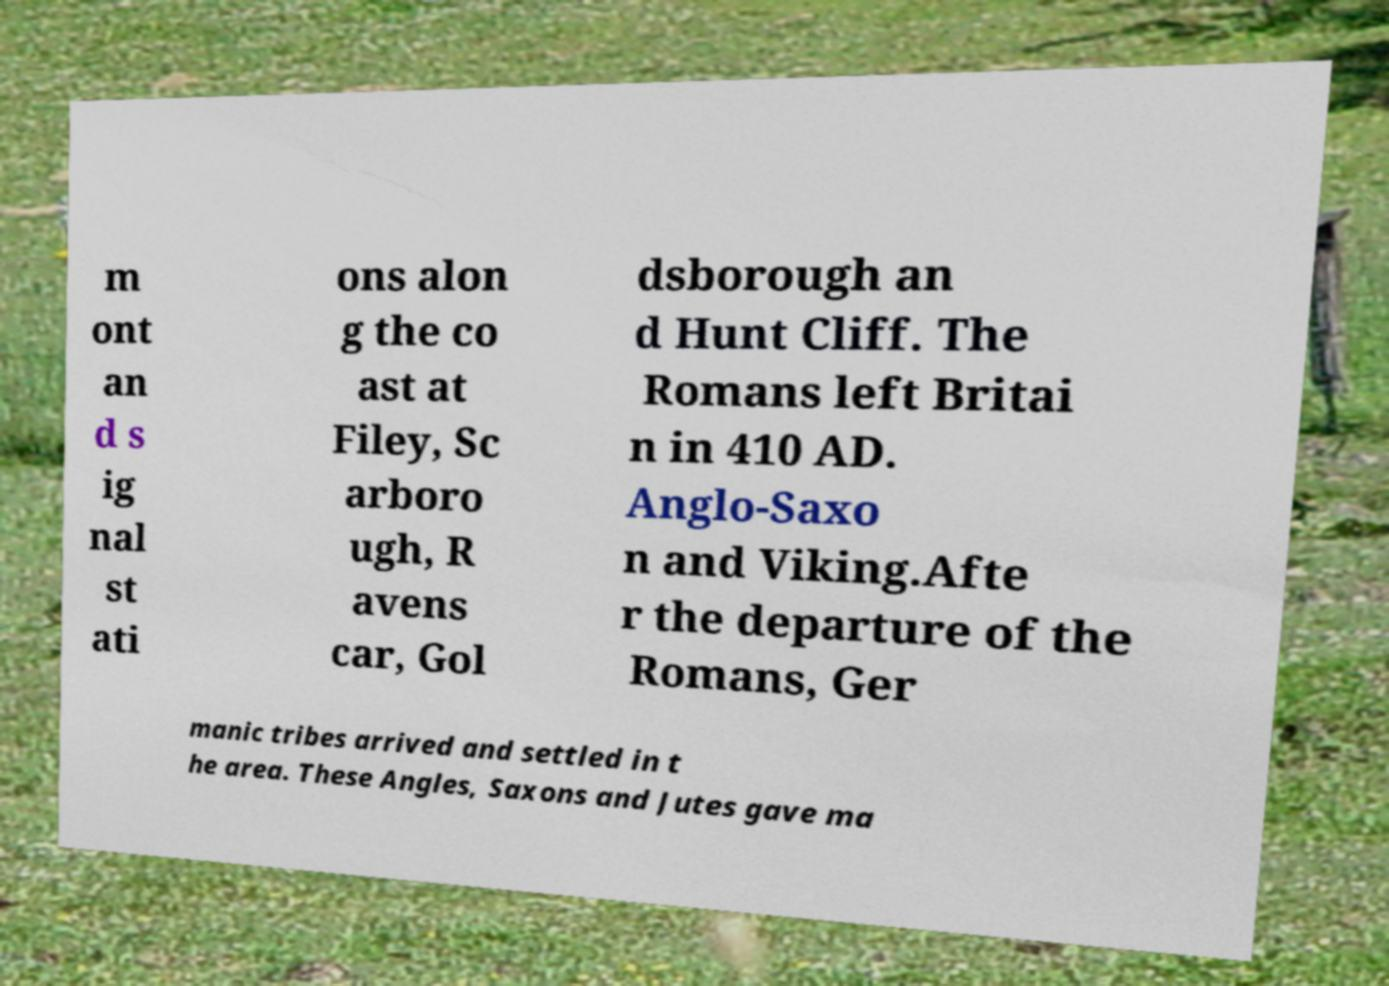Please read and relay the text visible in this image. What does it say? m ont an d s ig nal st ati ons alon g the co ast at Filey, Sc arboro ugh, R avens car, Gol dsborough an d Hunt Cliff. The Romans left Britai n in 410 AD. Anglo-Saxo n and Viking.Afte r the departure of the Romans, Ger manic tribes arrived and settled in t he area. These Angles, Saxons and Jutes gave ma 